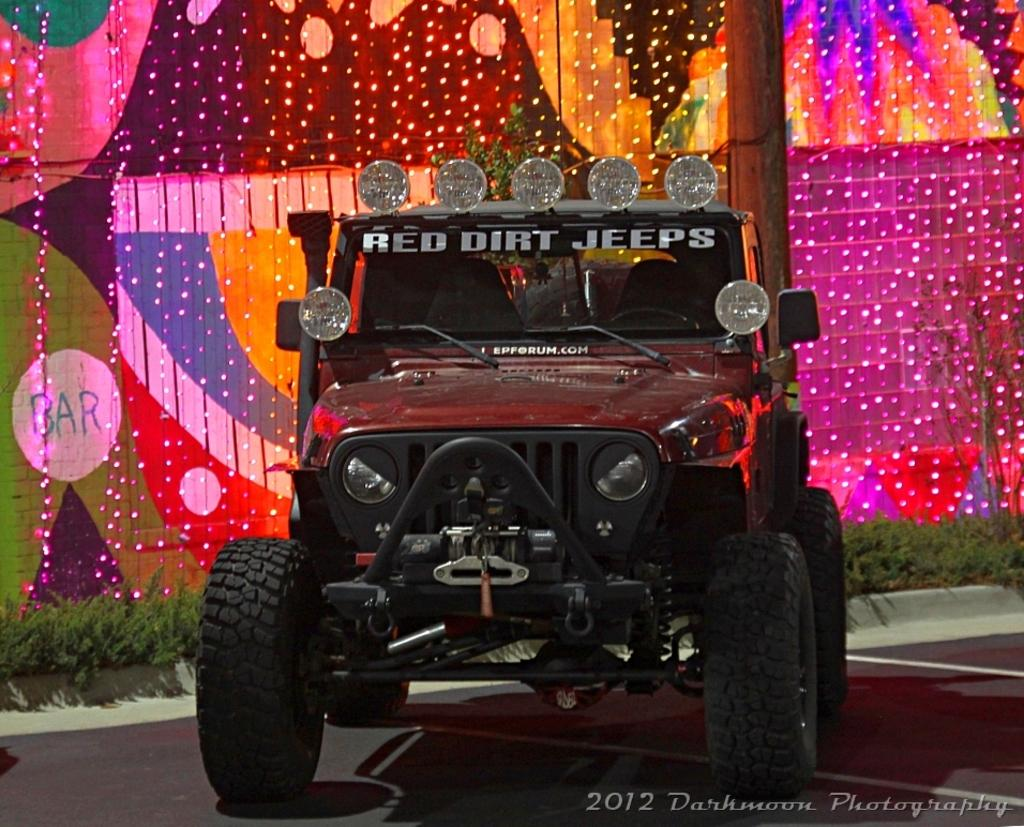What is the main subject in the foreground of the image? There is a jeep in the foreground of the image. What can be seen behind the jeep? There are plants visible behind the jeep. Can you describe the lighting in the image? There are many lights in the image. What position does the beginner driver hold in the image? There is no mention of a beginner driver or any driver in the image, so it is not possible to answer that question. 